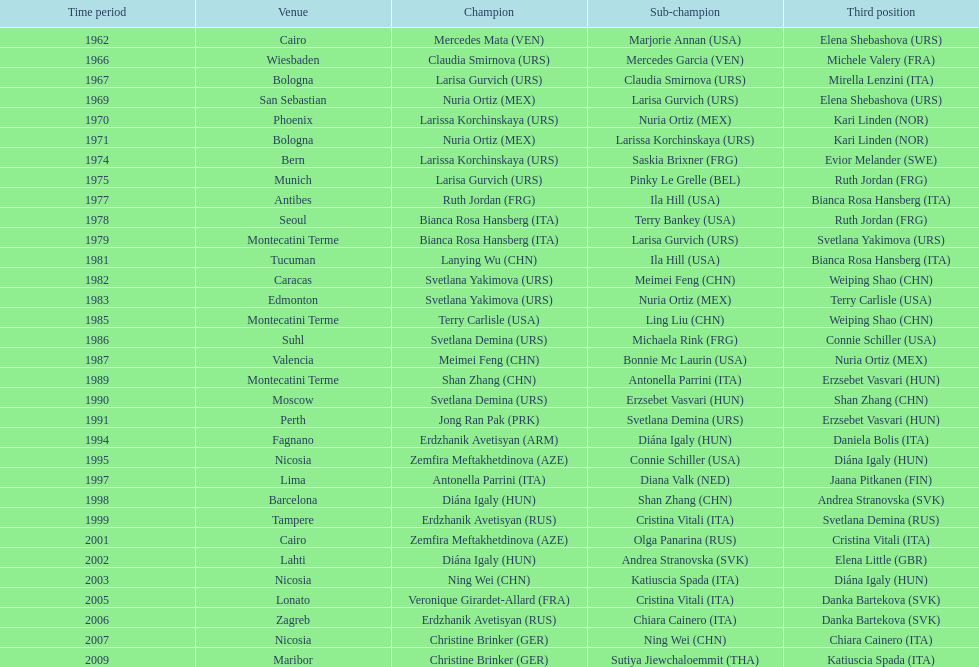What is the total of silver for cairo 0. 